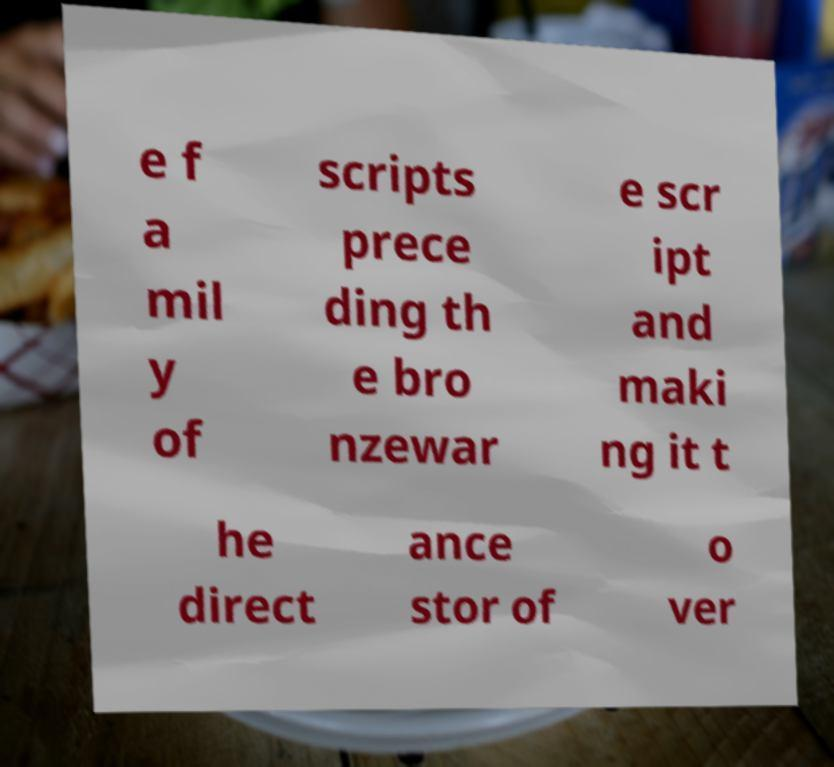For documentation purposes, I need the text within this image transcribed. Could you provide that? e f a mil y of scripts prece ding th e bro nzewar e scr ipt and maki ng it t he direct ance stor of o ver 